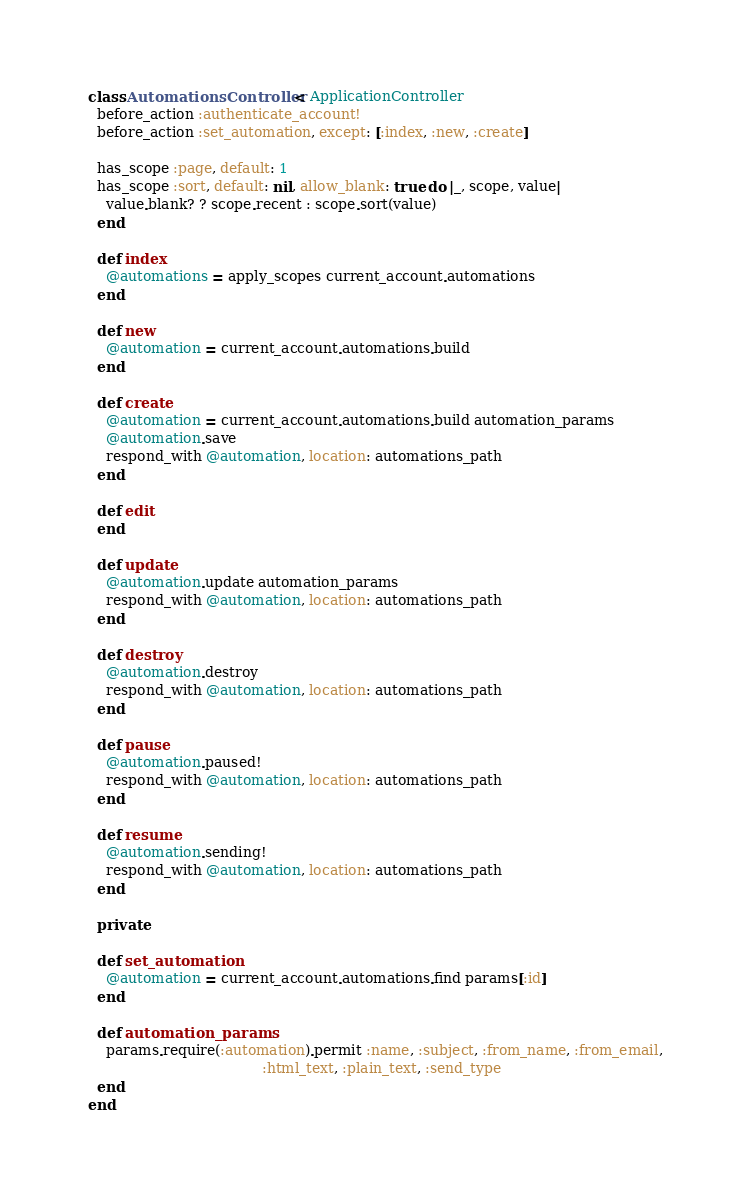<code> <loc_0><loc_0><loc_500><loc_500><_Ruby_>class AutomationsController < ApplicationController
  before_action :authenticate_account!
  before_action :set_automation, except: [:index, :new, :create]

  has_scope :page, default: 1
  has_scope :sort, default: nil, allow_blank: true do |_, scope, value|
    value.blank? ? scope.recent : scope.sort(value)
  end

  def index
    @automations = apply_scopes current_account.automations
  end

  def new
    @automation = current_account.automations.build
  end

  def create
    @automation = current_account.automations.build automation_params
    @automation.save
    respond_with @automation, location: automations_path
  end

  def edit
  end

  def update
    @automation.update automation_params
    respond_with @automation, location: automations_path
  end

  def destroy
    @automation.destroy
    respond_with @automation, location: automations_path
  end

  def pause
    @automation.paused!
    respond_with @automation, location: automations_path
  end

  def resume
    @automation.sending!
    respond_with @automation, location: automations_path
  end

  private

  def set_automation
    @automation = current_account.automations.find params[:id]
  end

  def automation_params
    params.require(:automation).permit :name, :subject, :from_name, :from_email,
                                       :html_text, :plain_text, :send_type
  end
end
</code> 